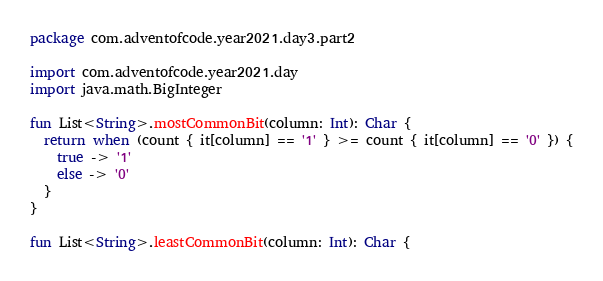<code> <loc_0><loc_0><loc_500><loc_500><_Kotlin_>package com.adventofcode.year2021.day3.part2

import com.adventofcode.year2021.day
import java.math.BigInteger

fun List<String>.mostCommonBit(column: Int): Char {
  return when (count { it[column] == '1' } >= count { it[column] == '0' }) {
    true -> '1'
    else -> '0'
  }
}

fun List<String>.leastCommonBit(column: Int): Char {</code> 